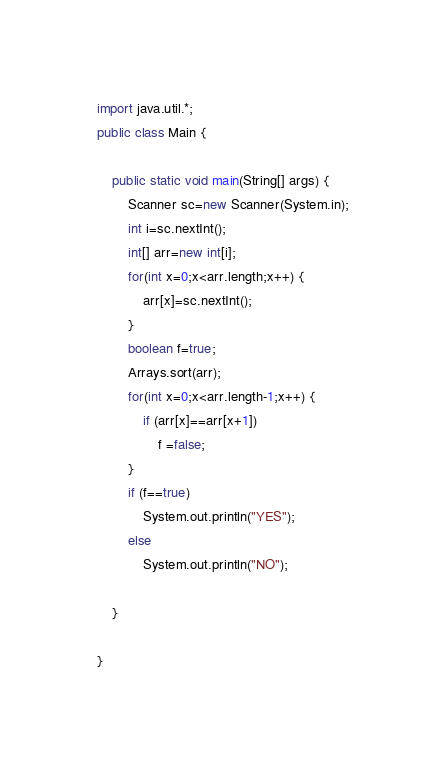Convert code to text. <code><loc_0><loc_0><loc_500><loc_500><_Java_>import java.util.*;
public class Main {

	public static void main(String[] args) {
		Scanner sc=new Scanner(System.in);
		int i=sc.nextInt();
		int[] arr=new int[i];
		for(int x=0;x<arr.length;x++) {
			arr[x]=sc.nextInt();
		}
		boolean f=true;
		Arrays.sort(arr);
		for(int x=0;x<arr.length-1;x++) {
			if (arr[x]==arr[x+1])
				f =false;
		}
		if (f==true)
			System.out.println("YES");
		else 
			System.out.println("NO");
		
	}

}
</code> 